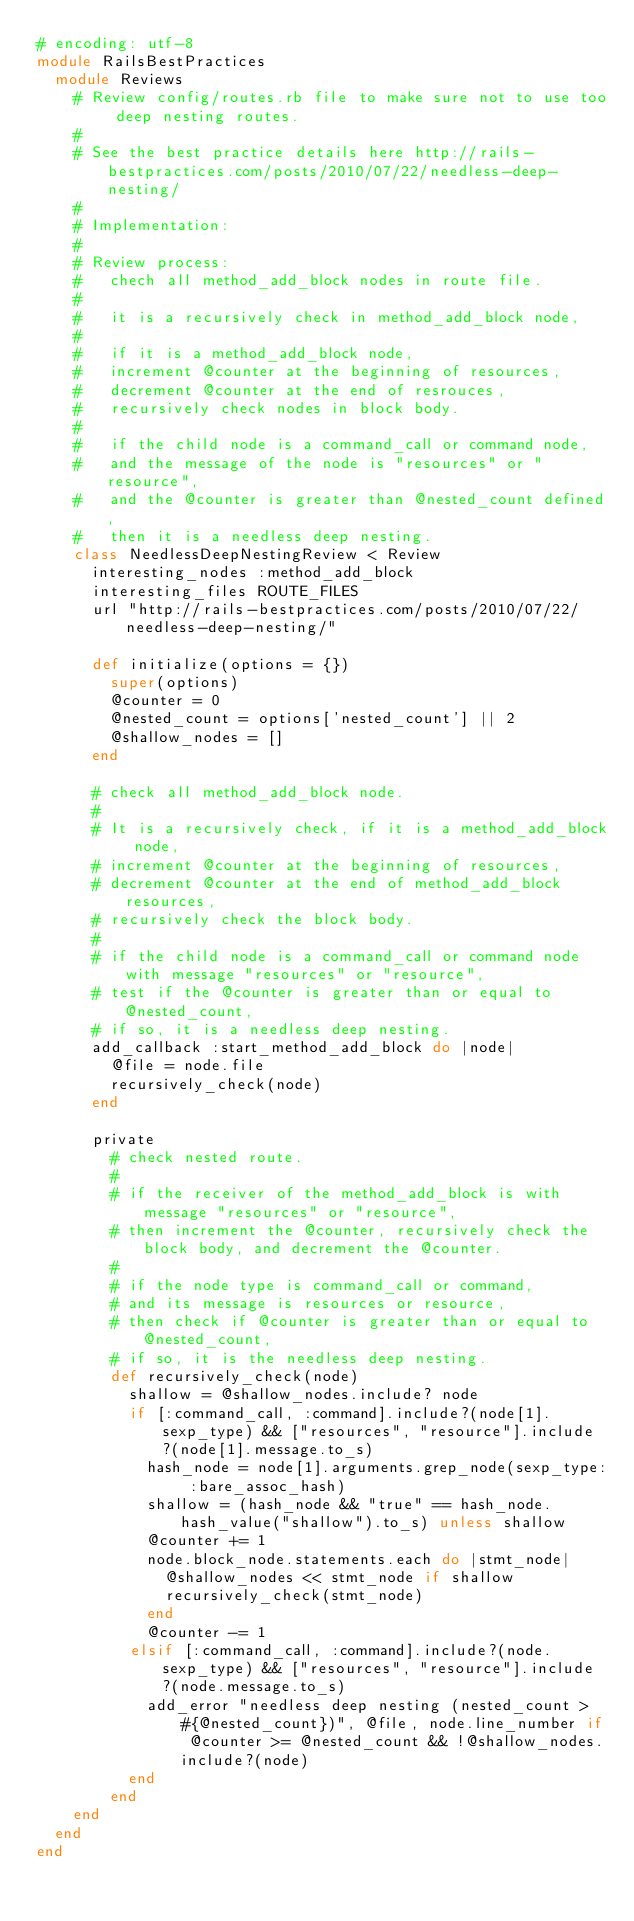Convert code to text. <code><loc_0><loc_0><loc_500><loc_500><_Ruby_># encoding: utf-8
module RailsBestPractices
  module Reviews
    # Review config/routes.rb file to make sure not to use too deep nesting routes.
    #
    # See the best practice details here http://rails-bestpractices.com/posts/2010/07/22/needless-deep-nesting/
    #
    # Implementation:
    #
    # Review process:
    #   chech all method_add_block nodes in route file.
    #
    #   it is a recursively check in method_add_block node,
    #
    #   if it is a method_add_block node,
    #   increment @counter at the beginning of resources,
    #   decrement @counter at the end of resrouces,
    #   recursively check nodes in block body.
    #
    #   if the child node is a command_call or command node,
    #   and the message of the node is "resources" or "resource",
    #   and the @counter is greater than @nested_count defined,
    #   then it is a needless deep nesting.
    class NeedlessDeepNestingReview < Review
      interesting_nodes :method_add_block
      interesting_files ROUTE_FILES
      url "http://rails-bestpractices.com/posts/2010/07/22/needless-deep-nesting/"

      def initialize(options = {})
        super(options)
        @counter = 0
        @nested_count = options['nested_count'] || 2
        @shallow_nodes = []
      end

      # check all method_add_block node.
      #
      # It is a recursively check, if it is a method_add_block node,
      # increment @counter at the beginning of resources,
      # decrement @counter at the end of method_add_block resources,
      # recursively check the block body.
      #
      # if the child node is a command_call or command node with message "resources" or "resource",
      # test if the @counter is greater than or equal to @nested_count,
      # if so, it is a needless deep nesting.
      add_callback :start_method_add_block do |node|
        @file = node.file
        recursively_check(node)
      end

      private
        # check nested route.
        #
        # if the receiver of the method_add_block is with message "resources" or "resource",
        # then increment the @counter, recursively check the block body, and decrement the @counter.
        #
        # if the node type is command_call or command,
        # and its message is resources or resource,
        # then check if @counter is greater than or equal to @nested_count,
        # if so, it is the needless deep nesting.
        def recursively_check(node)
          shallow = @shallow_nodes.include? node
          if [:command_call, :command].include?(node[1].sexp_type) && ["resources", "resource"].include?(node[1].message.to_s)
            hash_node = node[1].arguments.grep_node(sexp_type: :bare_assoc_hash)
            shallow = (hash_node && "true" == hash_node.hash_value("shallow").to_s) unless shallow
            @counter += 1
            node.block_node.statements.each do |stmt_node|
              @shallow_nodes << stmt_node if shallow
              recursively_check(stmt_node)
            end
            @counter -= 1
          elsif [:command_call, :command].include?(node.sexp_type) && ["resources", "resource"].include?(node.message.to_s)
            add_error "needless deep nesting (nested_count > #{@nested_count})", @file, node.line_number if @counter >= @nested_count && !@shallow_nodes.include?(node)
          end
        end
    end
  end
end
</code> 